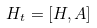Convert formula to latex. <formula><loc_0><loc_0><loc_500><loc_500>H _ { t } = [ H , A ]</formula> 